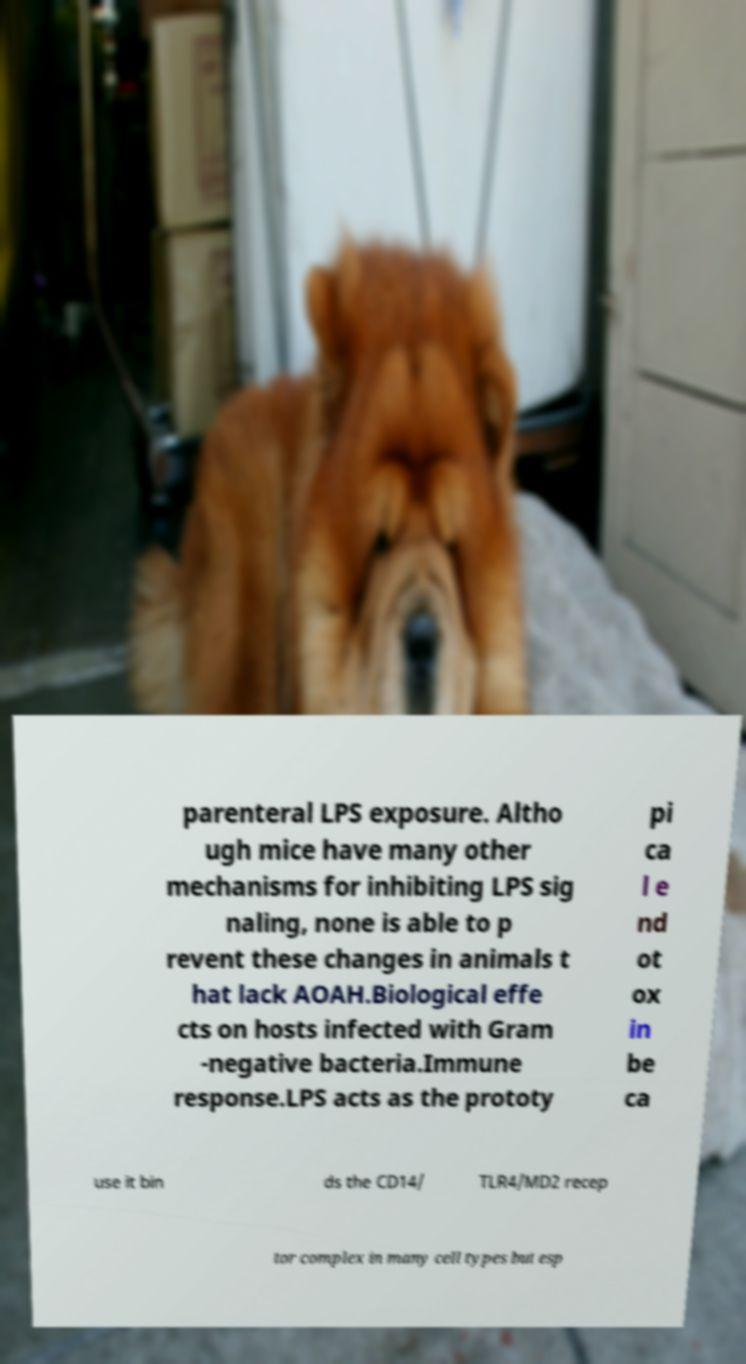Please identify and transcribe the text found in this image. parenteral LPS exposure. Altho ugh mice have many other mechanisms for inhibiting LPS sig naling, none is able to p revent these changes in animals t hat lack AOAH.Biological effe cts on hosts infected with Gram -negative bacteria.Immune response.LPS acts as the prototy pi ca l e nd ot ox in be ca use it bin ds the CD14/ TLR4/MD2 recep tor complex in many cell types but esp 